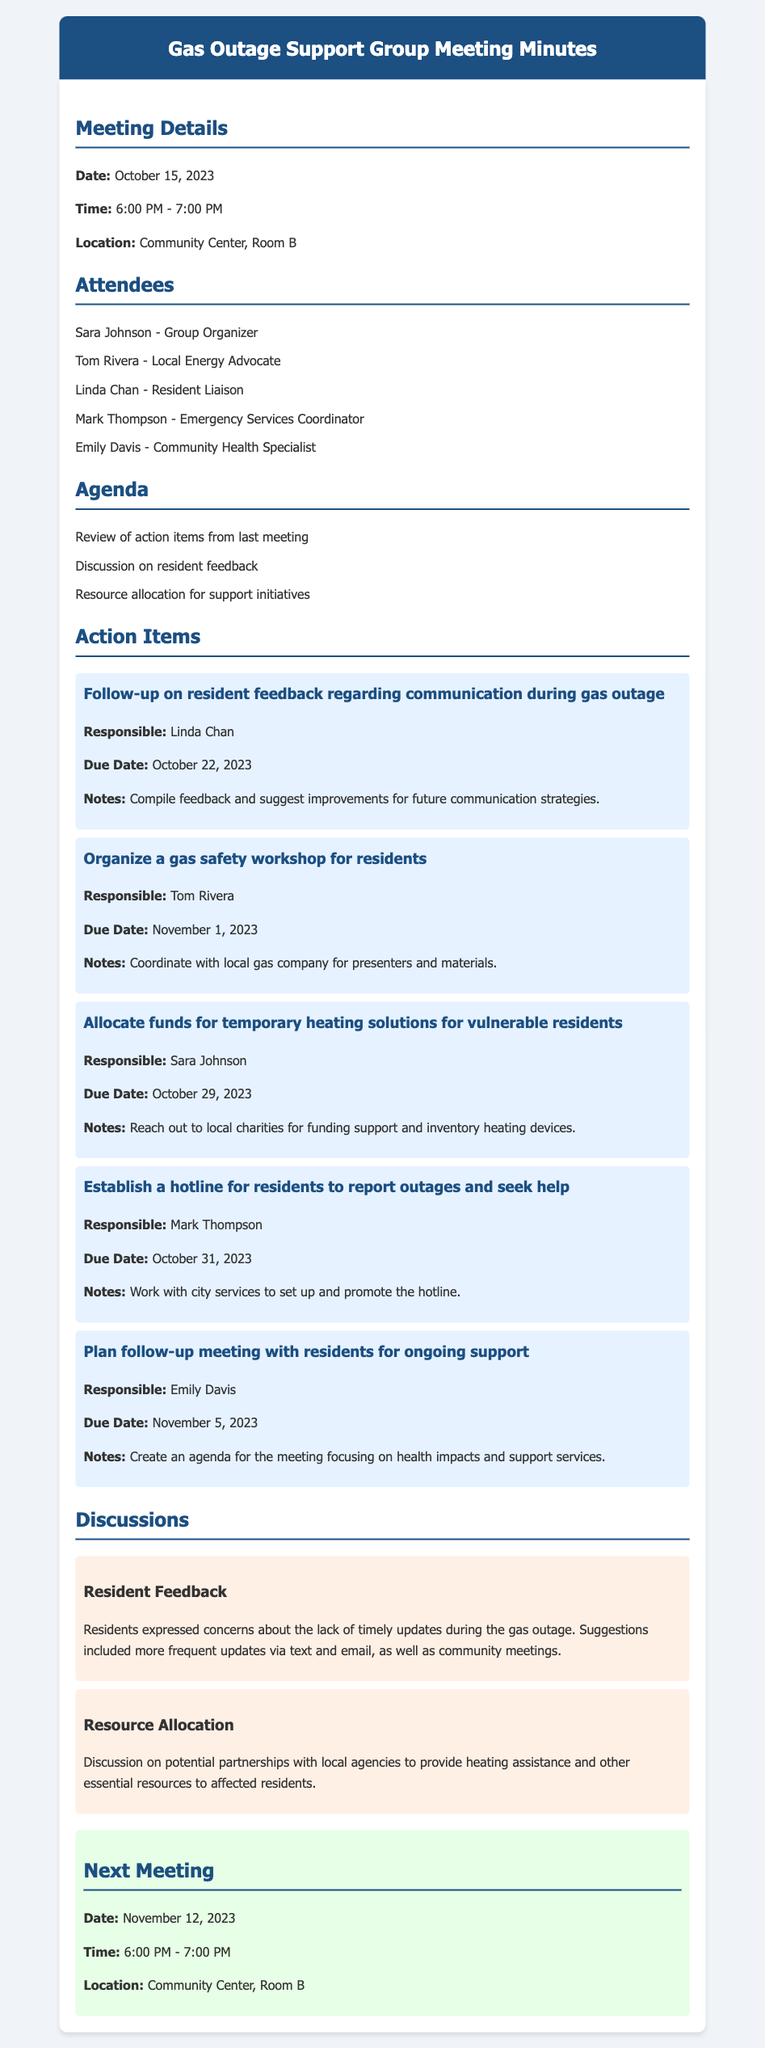What is the date of the meeting? The date of the meeting is specified at the beginning of the document.
Answer: October 15, 2023 Who is responsible for organizing the gas safety workshop? The responsible person's name is provided under the action items section in the document.
Answer: Tom Rivera What is the due date for allocating funds for temporary heating solutions? The due date is listed in the relevant action item within the document.
Answer: October 29, 2023 What feedback did residents express during the discussion? The document provides a summary of resident concerns in the discussion section.
Answer: Lack of timely updates What is the main purpose of the next meeting? The purpose of the next meeting can be inferred from the discussion about ongoing support described in the meetings section.
Answer: Ongoing support How many attendees were present at the meeting? The number of attendees is listed in the attendees section of the document.
Answer: Five What resources are being allocated for vulnerable residents? The document outlines specific actions related to resource allocation in the action items.
Answer: Temporary heating solutions What is one suggestion residents made for improving communication? Suggestions from residents regarding communication improvements are summarized in the discussion section.
Answer: More frequent updates via text and email Who will compile the feedback and suggest improvements? The responsible person's name is provided in the specific action item regarding feedback.
Answer: Linda Chan 